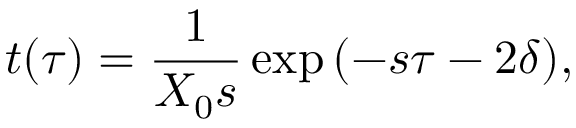<formula> <loc_0><loc_0><loc_500><loc_500>t ( \tau ) = \frac { 1 } X _ { 0 } s } \exp { ( - s \tau - 2 \delta ) } ,</formula> 